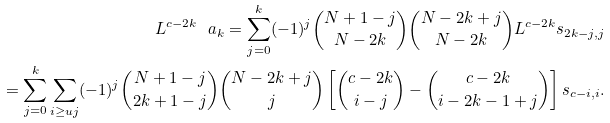<formula> <loc_0><loc_0><loc_500><loc_500>L ^ { c - 2 k } \ a _ { k } = \sum _ { j = 0 } ^ { k } ( - 1 ) ^ { j } \binom { N + 1 - j } { N - 2 k } \binom { N - 2 k + j } { N - 2 k } L ^ { c - 2 k } s _ { 2 k - j , j } \\ = \sum _ { j = 0 } ^ { k } \sum _ { i \geq u j } ( - 1 ) ^ { j } \binom { N + 1 - j } { 2 k + 1 - j } \binom { N - 2 k + j } { j } \left [ \binom { c - 2 k } { i - j } - \binom { c - 2 k } { i - 2 k - 1 + j } \right ] s _ { c - i , i } .</formula> 